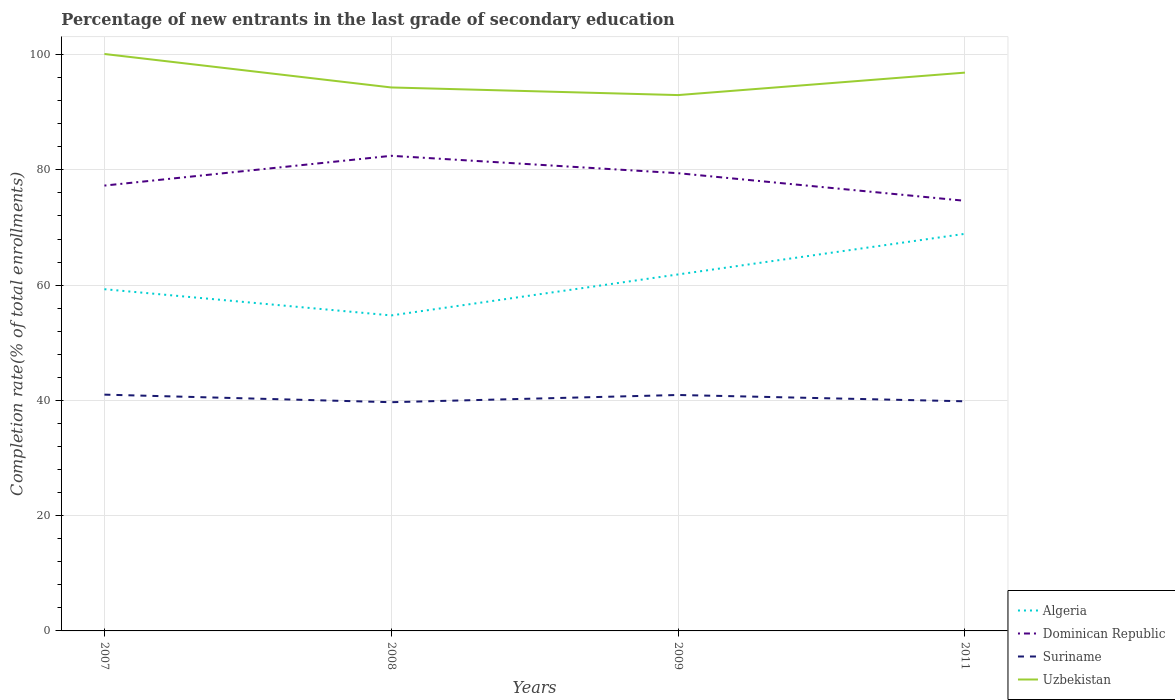Across all years, what is the maximum percentage of new entrants in Algeria?
Provide a short and direct response. 54.74. What is the total percentage of new entrants in Uzbekistan in the graph?
Your response must be concise. -2.57. What is the difference between the highest and the second highest percentage of new entrants in Algeria?
Give a very brief answer. 14.16. What is the difference between the highest and the lowest percentage of new entrants in Algeria?
Keep it short and to the point. 2. How many years are there in the graph?
Give a very brief answer. 4. What is the difference between two consecutive major ticks on the Y-axis?
Keep it short and to the point. 20. Are the values on the major ticks of Y-axis written in scientific E-notation?
Make the answer very short. No. Does the graph contain grids?
Give a very brief answer. Yes. How many legend labels are there?
Keep it short and to the point. 4. What is the title of the graph?
Provide a succinct answer. Percentage of new entrants in the last grade of secondary education. Does "Guyana" appear as one of the legend labels in the graph?
Give a very brief answer. No. What is the label or title of the X-axis?
Provide a succinct answer. Years. What is the label or title of the Y-axis?
Your answer should be very brief. Completion rate(% of total enrollments). What is the Completion rate(% of total enrollments) of Algeria in 2007?
Your answer should be very brief. 59.29. What is the Completion rate(% of total enrollments) of Dominican Republic in 2007?
Offer a terse response. 77.27. What is the Completion rate(% of total enrollments) in Suriname in 2007?
Make the answer very short. 41. What is the Completion rate(% of total enrollments) of Uzbekistan in 2007?
Ensure brevity in your answer.  100.11. What is the Completion rate(% of total enrollments) of Algeria in 2008?
Your answer should be very brief. 54.74. What is the Completion rate(% of total enrollments) of Dominican Republic in 2008?
Offer a very short reply. 82.44. What is the Completion rate(% of total enrollments) in Suriname in 2008?
Your answer should be very brief. 39.69. What is the Completion rate(% of total enrollments) of Uzbekistan in 2008?
Your answer should be very brief. 94.3. What is the Completion rate(% of total enrollments) of Algeria in 2009?
Offer a very short reply. 61.86. What is the Completion rate(% of total enrollments) of Dominican Republic in 2009?
Offer a terse response. 79.42. What is the Completion rate(% of total enrollments) of Suriname in 2009?
Your response must be concise. 40.94. What is the Completion rate(% of total enrollments) of Uzbekistan in 2009?
Give a very brief answer. 92.98. What is the Completion rate(% of total enrollments) in Algeria in 2011?
Provide a succinct answer. 68.9. What is the Completion rate(% of total enrollments) of Dominican Republic in 2011?
Provide a succinct answer. 74.63. What is the Completion rate(% of total enrollments) in Suriname in 2011?
Give a very brief answer. 39.84. What is the Completion rate(% of total enrollments) in Uzbekistan in 2011?
Provide a short and direct response. 96.87. Across all years, what is the maximum Completion rate(% of total enrollments) of Algeria?
Make the answer very short. 68.9. Across all years, what is the maximum Completion rate(% of total enrollments) in Dominican Republic?
Your answer should be compact. 82.44. Across all years, what is the maximum Completion rate(% of total enrollments) in Suriname?
Your answer should be very brief. 41. Across all years, what is the maximum Completion rate(% of total enrollments) of Uzbekistan?
Offer a terse response. 100.11. Across all years, what is the minimum Completion rate(% of total enrollments) of Algeria?
Your response must be concise. 54.74. Across all years, what is the minimum Completion rate(% of total enrollments) of Dominican Republic?
Keep it short and to the point. 74.63. Across all years, what is the minimum Completion rate(% of total enrollments) of Suriname?
Keep it short and to the point. 39.69. Across all years, what is the minimum Completion rate(% of total enrollments) in Uzbekistan?
Ensure brevity in your answer.  92.98. What is the total Completion rate(% of total enrollments) in Algeria in the graph?
Offer a very short reply. 244.8. What is the total Completion rate(% of total enrollments) in Dominican Republic in the graph?
Your answer should be very brief. 313.77. What is the total Completion rate(% of total enrollments) of Suriname in the graph?
Provide a succinct answer. 161.47. What is the total Completion rate(% of total enrollments) in Uzbekistan in the graph?
Give a very brief answer. 384.26. What is the difference between the Completion rate(% of total enrollments) in Algeria in 2007 and that in 2008?
Your answer should be compact. 4.55. What is the difference between the Completion rate(% of total enrollments) of Dominican Republic in 2007 and that in 2008?
Provide a short and direct response. -5.17. What is the difference between the Completion rate(% of total enrollments) of Suriname in 2007 and that in 2008?
Offer a terse response. 1.31. What is the difference between the Completion rate(% of total enrollments) of Uzbekistan in 2007 and that in 2008?
Ensure brevity in your answer.  5.81. What is the difference between the Completion rate(% of total enrollments) in Algeria in 2007 and that in 2009?
Give a very brief answer. -2.56. What is the difference between the Completion rate(% of total enrollments) of Dominican Republic in 2007 and that in 2009?
Provide a short and direct response. -2.15. What is the difference between the Completion rate(% of total enrollments) in Suriname in 2007 and that in 2009?
Your response must be concise. 0.06. What is the difference between the Completion rate(% of total enrollments) in Uzbekistan in 2007 and that in 2009?
Ensure brevity in your answer.  7.13. What is the difference between the Completion rate(% of total enrollments) in Algeria in 2007 and that in 2011?
Offer a very short reply. -9.61. What is the difference between the Completion rate(% of total enrollments) of Dominican Republic in 2007 and that in 2011?
Offer a very short reply. 2.64. What is the difference between the Completion rate(% of total enrollments) of Suriname in 2007 and that in 2011?
Make the answer very short. 1.16. What is the difference between the Completion rate(% of total enrollments) of Uzbekistan in 2007 and that in 2011?
Make the answer very short. 3.23. What is the difference between the Completion rate(% of total enrollments) in Algeria in 2008 and that in 2009?
Give a very brief answer. -7.11. What is the difference between the Completion rate(% of total enrollments) in Dominican Republic in 2008 and that in 2009?
Give a very brief answer. 3.02. What is the difference between the Completion rate(% of total enrollments) in Suriname in 2008 and that in 2009?
Provide a succinct answer. -1.25. What is the difference between the Completion rate(% of total enrollments) of Uzbekistan in 2008 and that in 2009?
Your answer should be very brief. 1.32. What is the difference between the Completion rate(% of total enrollments) of Algeria in 2008 and that in 2011?
Make the answer very short. -14.16. What is the difference between the Completion rate(% of total enrollments) of Dominican Republic in 2008 and that in 2011?
Give a very brief answer. 7.81. What is the difference between the Completion rate(% of total enrollments) of Suriname in 2008 and that in 2011?
Offer a terse response. -0.16. What is the difference between the Completion rate(% of total enrollments) in Uzbekistan in 2008 and that in 2011?
Your response must be concise. -2.57. What is the difference between the Completion rate(% of total enrollments) of Algeria in 2009 and that in 2011?
Your answer should be very brief. -7.05. What is the difference between the Completion rate(% of total enrollments) of Dominican Republic in 2009 and that in 2011?
Your answer should be compact. 4.79. What is the difference between the Completion rate(% of total enrollments) of Suriname in 2009 and that in 2011?
Offer a very short reply. 1.09. What is the difference between the Completion rate(% of total enrollments) of Uzbekistan in 2009 and that in 2011?
Offer a very short reply. -3.9. What is the difference between the Completion rate(% of total enrollments) in Algeria in 2007 and the Completion rate(% of total enrollments) in Dominican Republic in 2008?
Offer a very short reply. -23.15. What is the difference between the Completion rate(% of total enrollments) of Algeria in 2007 and the Completion rate(% of total enrollments) of Suriname in 2008?
Offer a very short reply. 19.61. What is the difference between the Completion rate(% of total enrollments) in Algeria in 2007 and the Completion rate(% of total enrollments) in Uzbekistan in 2008?
Provide a succinct answer. -35.01. What is the difference between the Completion rate(% of total enrollments) of Dominican Republic in 2007 and the Completion rate(% of total enrollments) of Suriname in 2008?
Offer a very short reply. 37.59. What is the difference between the Completion rate(% of total enrollments) of Dominican Republic in 2007 and the Completion rate(% of total enrollments) of Uzbekistan in 2008?
Your response must be concise. -17.03. What is the difference between the Completion rate(% of total enrollments) in Suriname in 2007 and the Completion rate(% of total enrollments) in Uzbekistan in 2008?
Give a very brief answer. -53.3. What is the difference between the Completion rate(% of total enrollments) in Algeria in 2007 and the Completion rate(% of total enrollments) in Dominican Republic in 2009?
Give a very brief answer. -20.13. What is the difference between the Completion rate(% of total enrollments) of Algeria in 2007 and the Completion rate(% of total enrollments) of Suriname in 2009?
Offer a very short reply. 18.35. What is the difference between the Completion rate(% of total enrollments) in Algeria in 2007 and the Completion rate(% of total enrollments) in Uzbekistan in 2009?
Offer a very short reply. -33.68. What is the difference between the Completion rate(% of total enrollments) of Dominican Republic in 2007 and the Completion rate(% of total enrollments) of Suriname in 2009?
Your answer should be very brief. 36.33. What is the difference between the Completion rate(% of total enrollments) of Dominican Republic in 2007 and the Completion rate(% of total enrollments) of Uzbekistan in 2009?
Give a very brief answer. -15.7. What is the difference between the Completion rate(% of total enrollments) in Suriname in 2007 and the Completion rate(% of total enrollments) in Uzbekistan in 2009?
Your response must be concise. -51.98. What is the difference between the Completion rate(% of total enrollments) in Algeria in 2007 and the Completion rate(% of total enrollments) in Dominican Republic in 2011?
Offer a terse response. -15.34. What is the difference between the Completion rate(% of total enrollments) in Algeria in 2007 and the Completion rate(% of total enrollments) in Suriname in 2011?
Provide a succinct answer. 19.45. What is the difference between the Completion rate(% of total enrollments) of Algeria in 2007 and the Completion rate(% of total enrollments) of Uzbekistan in 2011?
Make the answer very short. -37.58. What is the difference between the Completion rate(% of total enrollments) of Dominican Republic in 2007 and the Completion rate(% of total enrollments) of Suriname in 2011?
Your answer should be very brief. 37.43. What is the difference between the Completion rate(% of total enrollments) of Dominican Republic in 2007 and the Completion rate(% of total enrollments) of Uzbekistan in 2011?
Ensure brevity in your answer.  -19.6. What is the difference between the Completion rate(% of total enrollments) of Suriname in 2007 and the Completion rate(% of total enrollments) of Uzbekistan in 2011?
Your answer should be compact. -55.87. What is the difference between the Completion rate(% of total enrollments) of Algeria in 2008 and the Completion rate(% of total enrollments) of Dominican Republic in 2009?
Your answer should be very brief. -24.68. What is the difference between the Completion rate(% of total enrollments) of Algeria in 2008 and the Completion rate(% of total enrollments) of Suriname in 2009?
Your answer should be compact. 13.81. What is the difference between the Completion rate(% of total enrollments) in Algeria in 2008 and the Completion rate(% of total enrollments) in Uzbekistan in 2009?
Offer a very short reply. -38.23. What is the difference between the Completion rate(% of total enrollments) in Dominican Republic in 2008 and the Completion rate(% of total enrollments) in Suriname in 2009?
Provide a succinct answer. 41.5. What is the difference between the Completion rate(% of total enrollments) in Dominican Republic in 2008 and the Completion rate(% of total enrollments) in Uzbekistan in 2009?
Your answer should be very brief. -10.54. What is the difference between the Completion rate(% of total enrollments) in Suriname in 2008 and the Completion rate(% of total enrollments) in Uzbekistan in 2009?
Provide a succinct answer. -53.29. What is the difference between the Completion rate(% of total enrollments) of Algeria in 2008 and the Completion rate(% of total enrollments) of Dominican Republic in 2011?
Your response must be concise. -19.89. What is the difference between the Completion rate(% of total enrollments) in Algeria in 2008 and the Completion rate(% of total enrollments) in Suriname in 2011?
Ensure brevity in your answer.  14.9. What is the difference between the Completion rate(% of total enrollments) in Algeria in 2008 and the Completion rate(% of total enrollments) in Uzbekistan in 2011?
Your answer should be compact. -42.13. What is the difference between the Completion rate(% of total enrollments) of Dominican Republic in 2008 and the Completion rate(% of total enrollments) of Suriname in 2011?
Provide a short and direct response. 42.6. What is the difference between the Completion rate(% of total enrollments) in Dominican Republic in 2008 and the Completion rate(% of total enrollments) in Uzbekistan in 2011?
Provide a succinct answer. -14.43. What is the difference between the Completion rate(% of total enrollments) of Suriname in 2008 and the Completion rate(% of total enrollments) of Uzbekistan in 2011?
Keep it short and to the point. -57.19. What is the difference between the Completion rate(% of total enrollments) in Algeria in 2009 and the Completion rate(% of total enrollments) in Dominican Republic in 2011?
Offer a terse response. -12.77. What is the difference between the Completion rate(% of total enrollments) in Algeria in 2009 and the Completion rate(% of total enrollments) in Suriname in 2011?
Your answer should be very brief. 22.01. What is the difference between the Completion rate(% of total enrollments) in Algeria in 2009 and the Completion rate(% of total enrollments) in Uzbekistan in 2011?
Ensure brevity in your answer.  -35.02. What is the difference between the Completion rate(% of total enrollments) in Dominican Republic in 2009 and the Completion rate(% of total enrollments) in Suriname in 2011?
Give a very brief answer. 39.58. What is the difference between the Completion rate(% of total enrollments) of Dominican Republic in 2009 and the Completion rate(% of total enrollments) of Uzbekistan in 2011?
Your answer should be compact. -17.45. What is the difference between the Completion rate(% of total enrollments) in Suriname in 2009 and the Completion rate(% of total enrollments) in Uzbekistan in 2011?
Your response must be concise. -55.94. What is the average Completion rate(% of total enrollments) in Algeria per year?
Offer a very short reply. 61.2. What is the average Completion rate(% of total enrollments) of Dominican Republic per year?
Keep it short and to the point. 78.44. What is the average Completion rate(% of total enrollments) in Suriname per year?
Give a very brief answer. 40.37. What is the average Completion rate(% of total enrollments) in Uzbekistan per year?
Your response must be concise. 96.06. In the year 2007, what is the difference between the Completion rate(% of total enrollments) of Algeria and Completion rate(% of total enrollments) of Dominican Republic?
Your answer should be compact. -17.98. In the year 2007, what is the difference between the Completion rate(% of total enrollments) of Algeria and Completion rate(% of total enrollments) of Suriname?
Your answer should be compact. 18.29. In the year 2007, what is the difference between the Completion rate(% of total enrollments) in Algeria and Completion rate(% of total enrollments) in Uzbekistan?
Provide a succinct answer. -40.81. In the year 2007, what is the difference between the Completion rate(% of total enrollments) of Dominican Republic and Completion rate(% of total enrollments) of Suriname?
Ensure brevity in your answer.  36.27. In the year 2007, what is the difference between the Completion rate(% of total enrollments) of Dominican Republic and Completion rate(% of total enrollments) of Uzbekistan?
Give a very brief answer. -22.83. In the year 2007, what is the difference between the Completion rate(% of total enrollments) of Suriname and Completion rate(% of total enrollments) of Uzbekistan?
Make the answer very short. -59.11. In the year 2008, what is the difference between the Completion rate(% of total enrollments) of Algeria and Completion rate(% of total enrollments) of Dominican Republic?
Your answer should be very brief. -27.7. In the year 2008, what is the difference between the Completion rate(% of total enrollments) in Algeria and Completion rate(% of total enrollments) in Suriname?
Your answer should be compact. 15.06. In the year 2008, what is the difference between the Completion rate(% of total enrollments) of Algeria and Completion rate(% of total enrollments) of Uzbekistan?
Give a very brief answer. -39.56. In the year 2008, what is the difference between the Completion rate(% of total enrollments) in Dominican Republic and Completion rate(% of total enrollments) in Suriname?
Offer a very short reply. 42.75. In the year 2008, what is the difference between the Completion rate(% of total enrollments) in Dominican Republic and Completion rate(% of total enrollments) in Uzbekistan?
Offer a very short reply. -11.86. In the year 2008, what is the difference between the Completion rate(% of total enrollments) in Suriname and Completion rate(% of total enrollments) in Uzbekistan?
Make the answer very short. -54.61. In the year 2009, what is the difference between the Completion rate(% of total enrollments) of Algeria and Completion rate(% of total enrollments) of Dominican Republic?
Offer a terse response. -17.57. In the year 2009, what is the difference between the Completion rate(% of total enrollments) in Algeria and Completion rate(% of total enrollments) in Suriname?
Your response must be concise. 20.92. In the year 2009, what is the difference between the Completion rate(% of total enrollments) of Algeria and Completion rate(% of total enrollments) of Uzbekistan?
Your answer should be compact. -31.12. In the year 2009, what is the difference between the Completion rate(% of total enrollments) of Dominican Republic and Completion rate(% of total enrollments) of Suriname?
Your response must be concise. 38.48. In the year 2009, what is the difference between the Completion rate(% of total enrollments) in Dominican Republic and Completion rate(% of total enrollments) in Uzbekistan?
Offer a terse response. -13.55. In the year 2009, what is the difference between the Completion rate(% of total enrollments) in Suriname and Completion rate(% of total enrollments) in Uzbekistan?
Offer a terse response. -52.04. In the year 2011, what is the difference between the Completion rate(% of total enrollments) of Algeria and Completion rate(% of total enrollments) of Dominican Republic?
Your response must be concise. -5.73. In the year 2011, what is the difference between the Completion rate(% of total enrollments) of Algeria and Completion rate(% of total enrollments) of Suriname?
Your response must be concise. 29.06. In the year 2011, what is the difference between the Completion rate(% of total enrollments) of Algeria and Completion rate(% of total enrollments) of Uzbekistan?
Ensure brevity in your answer.  -27.97. In the year 2011, what is the difference between the Completion rate(% of total enrollments) in Dominican Republic and Completion rate(% of total enrollments) in Suriname?
Offer a very short reply. 34.79. In the year 2011, what is the difference between the Completion rate(% of total enrollments) of Dominican Republic and Completion rate(% of total enrollments) of Uzbekistan?
Provide a short and direct response. -22.24. In the year 2011, what is the difference between the Completion rate(% of total enrollments) of Suriname and Completion rate(% of total enrollments) of Uzbekistan?
Your response must be concise. -57.03. What is the ratio of the Completion rate(% of total enrollments) in Algeria in 2007 to that in 2008?
Provide a succinct answer. 1.08. What is the ratio of the Completion rate(% of total enrollments) in Dominican Republic in 2007 to that in 2008?
Keep it short and to the point. 0.94. What is the ratio of the Completion rate(% of total enrollments) in Suriname in 2007 to that in 2008?
Your answer should be compact. 1.03. What is the ratio of the Completion rate(% of total enrollments) in Uzbekistan in 2007 to that in 2008?
Ensure brevity in your answer.  1.06. What is the ratio of the Completion rate(% of total enrollments) in Algeria in 2007 to that in 2009?
Make the answer very short. 0.96. What is the ratio of the Completion rate(% of total enrollments) in Dominican Republic in 2007 to that in 2009?
Offer a terse response. 0.97. What is the ratio of the Completion rate(% of total enrollments) in Suriname in 2007 to that in 2009?
Your answer should be compact. 1. What is the ratio of the Completion rate(% of total enrollments) in Uzbekistan in 2007 to that in 2009?
Ensure brevity in your answer.  1.08. What is the ratio of the Completion rate(% of total enrollments) in Algeria in 2007 to that in 2011?
Your answer should be very brief. 0.86. What is the ratio of the Completion rate(% of total enrollments) in Dominican Republic in 2007 to that in 2011?
Keep it short and to the point. 1.04. What is the ratio of the Completion rate(% of total enrollments) in Uzbekistan in 2007 to that in 2011?
Ensure brevity in your answer.  1.03. What is the ratio of the Completion rate(% of total enrollments) of Algeria in 2008 to that in 2009?
Offer a very short reply. 0.89. What is the ratio of the Completion rate(% of total enrollments) of Dominican Republic in 2008 to that in 2009?
Offer a terse response. 1.04. What is the ratio of the Completion rate(% of total enrollments) of Suriname in 2008 to that in 2009?
Make the answer very short. 0.97. What is the ratio of the Completion rate(% of total enrollments) of Uzbekistan in 2008 to that in 2009?
Keep it short and to the point. 1.01. What is the ratio of the Completion rate(% of total enrollments) of Algeria in 2008 to that in 2011?
Make the answer very short. 0.79. What is the ratio of the Completion rate(% of total enrollments) of Dominican Republic in 2008 to that in 2011?
Offer a terse response. 1.1. What is the ratio of the Completion rate(% of total enrollments) in Suriname in 2008 to that in 2011?
Your answer should be very brief. 1. What is the ratio of the Completion rate(% of total enrollments) in Uzbekistan in 2008 to that in 2011?
Offer a terse response. 0.97. What is the ratio of the Completion rate(% of total enrollments) of Algeria in 2009 to that in 2011?
Keep it short and to the point. 0.9. What is the ratio of the Completion rate(% of total enrollments) of Dominican Republic in 2009 to that in 2011?
Your response must be concise. 1.06. What is the ratio of the Completion rate(% of total enrollments) of Suriname in 2009 to that in 2011?
Offer a very short reply. 1.03. What is the ratio of the Completion rate(% of total enrollments) of Uzbekistan in 2009 to that in 2011?
Give a very brief answer. 0.96. What is the difference between the highest and the second highest Completion rate(% of total enrollments) in Algeria?
Your response must be concise. 7.05. What is the difference between the highest and the second highest Completion rate(% of total enrollments) in Dominican Republic?
Your response must be concise. 3.02. What is the difference between the highest and the second highest Completion rate(% of total enrollments) of Suriname?
Give a very brief answer. 0.06. What is the difference between the highest and the second highest Completion rate(% of total enrollments) in Uzbekistan?
Your answer should be compact. 3.23. What is the difference between the highest and the lowest Completion rate(% of total enrollments) in Algeria?
Your answer should be compact. 14.16. What is the difference between the highest and the lowest Completion rate(% of total enrollments) in Dominican Republic?
Provide a succinct answer. 7.81. What is the difference between the highest and the lowest Completion rate(% of total enrollments) of Suriname?
Provide a succinct answer. 1.31. What is the difference between the highest and the lowest Completion rate(% of total enrollments) of Uzbekistan?
Your response must be concise. 7.13. 